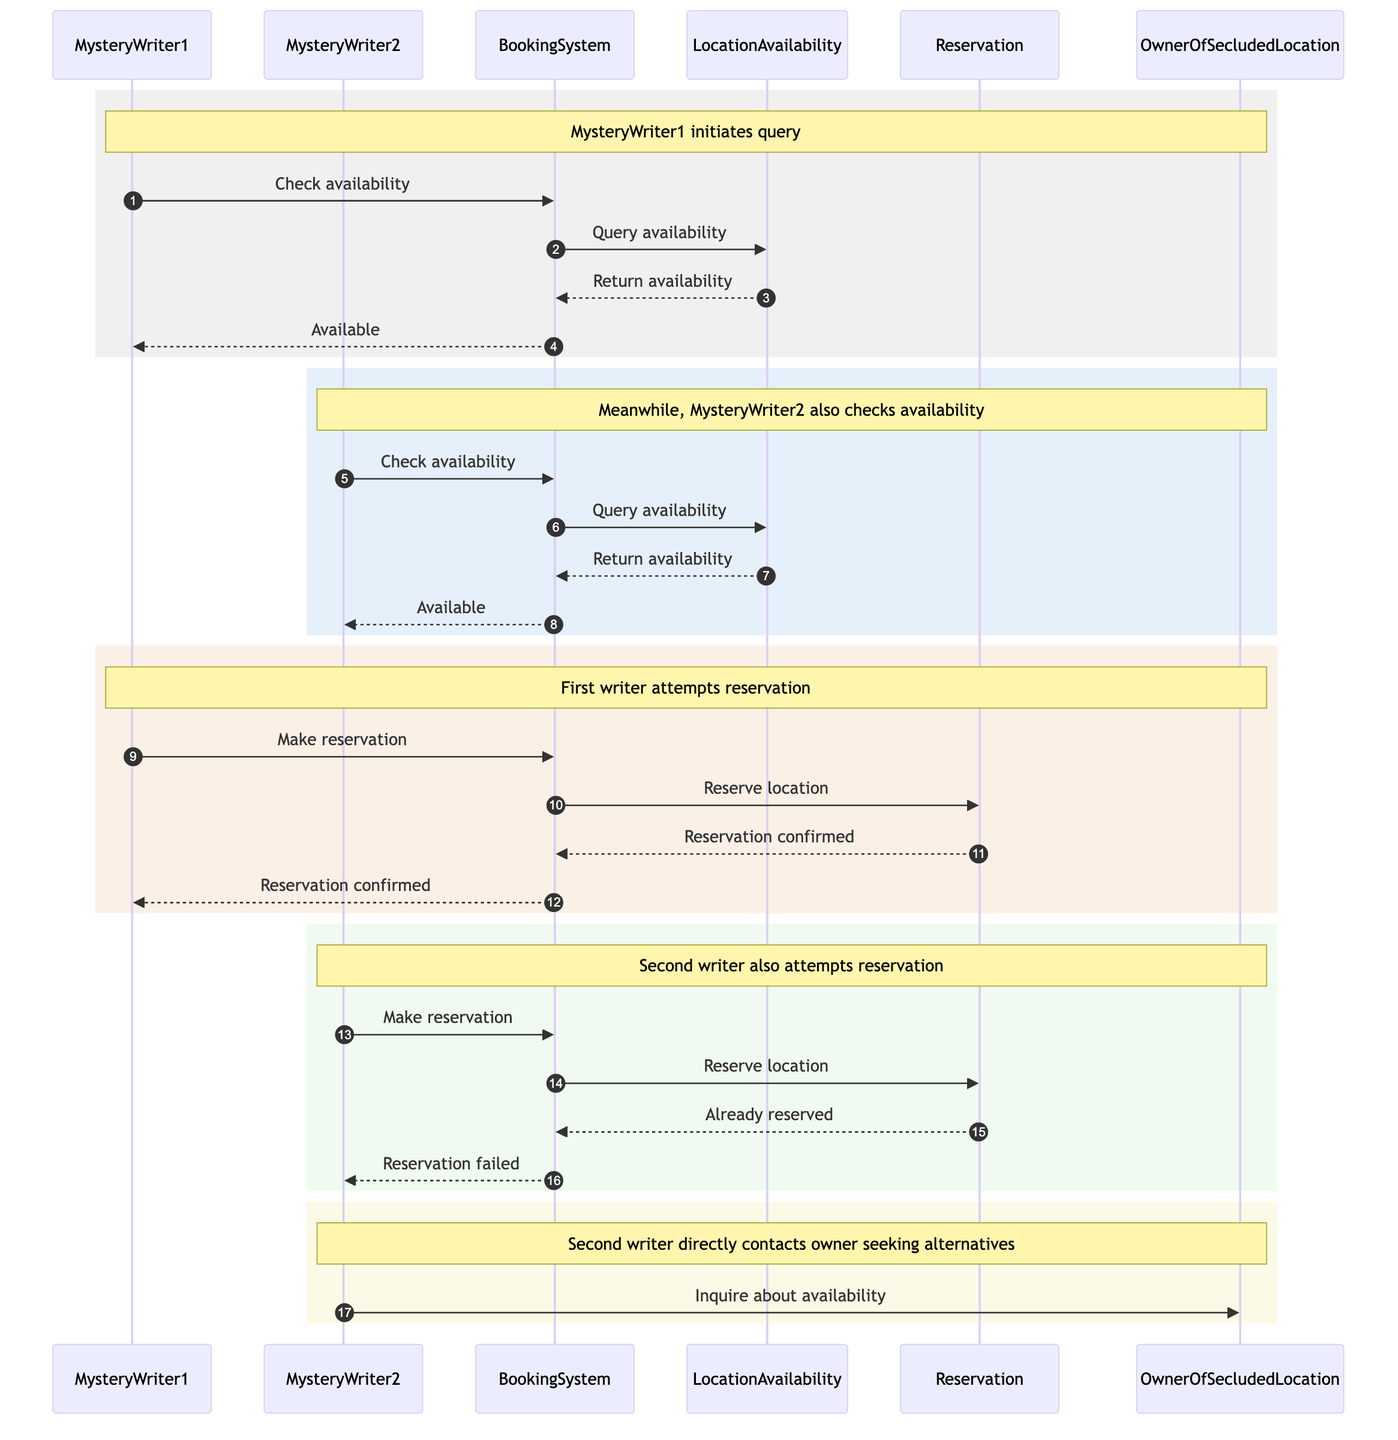What's the first action taken by MysteryWriter1? MysteryWriter1 initiates the process by sending a message to the BookingSystem to check for availability. This is indicated in the first interaction on the diagram.
Answer: Check availability How many main actors are depicted in this sequence? The diagram shows four main actors engaged in the sequence: MysteryWriter1, MysteryWriter2, OwnerOfSecludedLocation, and BookingSystem. Therefore, the total count of actors is determined by counting these distinct entities.
Answer: Four What is the message sent from BookingSystem to LocationAvailability? The message that the BookingSystem sends to LocationAvailability is a query regarding availability, which is represented in the second interaction on the diagram.
Answer: Query availability What happens after MysteryWriter1 makes a reservation? After MysteryWriter1 makes a reservation, the BookingSystem processes it, and the Reservation confirms that the location has been reserved. This sequence of actions is outlined in the steps following MysteryWriter1's reservation attempt.
Answer: Reservation confirmed What is the response given to MysteryWriter2 when they attempt to make a reservation? When MysteryWriter2 tries to reserve the location after it is already taken by MysteryWriter1, the BookingSystem replies that the reservation has failed, as indicated in the sequence's latter part.
Answer: Reservation failed How does MysteryWriter2 seek alternatives after their failed reservation? Following the failed reservation attempt, MysteryWriter2 directly inquires about availability with the OwnerOfSecludedLocation, as depicted in the last action of the sequence.
Answer: Inquire about availability What is the purpose of the "Return availability" message? The "Return availability" message from LocationAvailability back to BookingSystem serves to provide the initial availability status, enabling the BookingSystem to inform both MysteryWriter1 and MysteryWriter2 about the location's status.
Answer: To provide availability status Which writer has the first confirmed reservation? The sequence indicates that MysteryWriter1 is the first to receive a confirmation of their reservation after successfully completing the reservation process, making it clear who secured the location first.
Answer: MysteryWriter1 